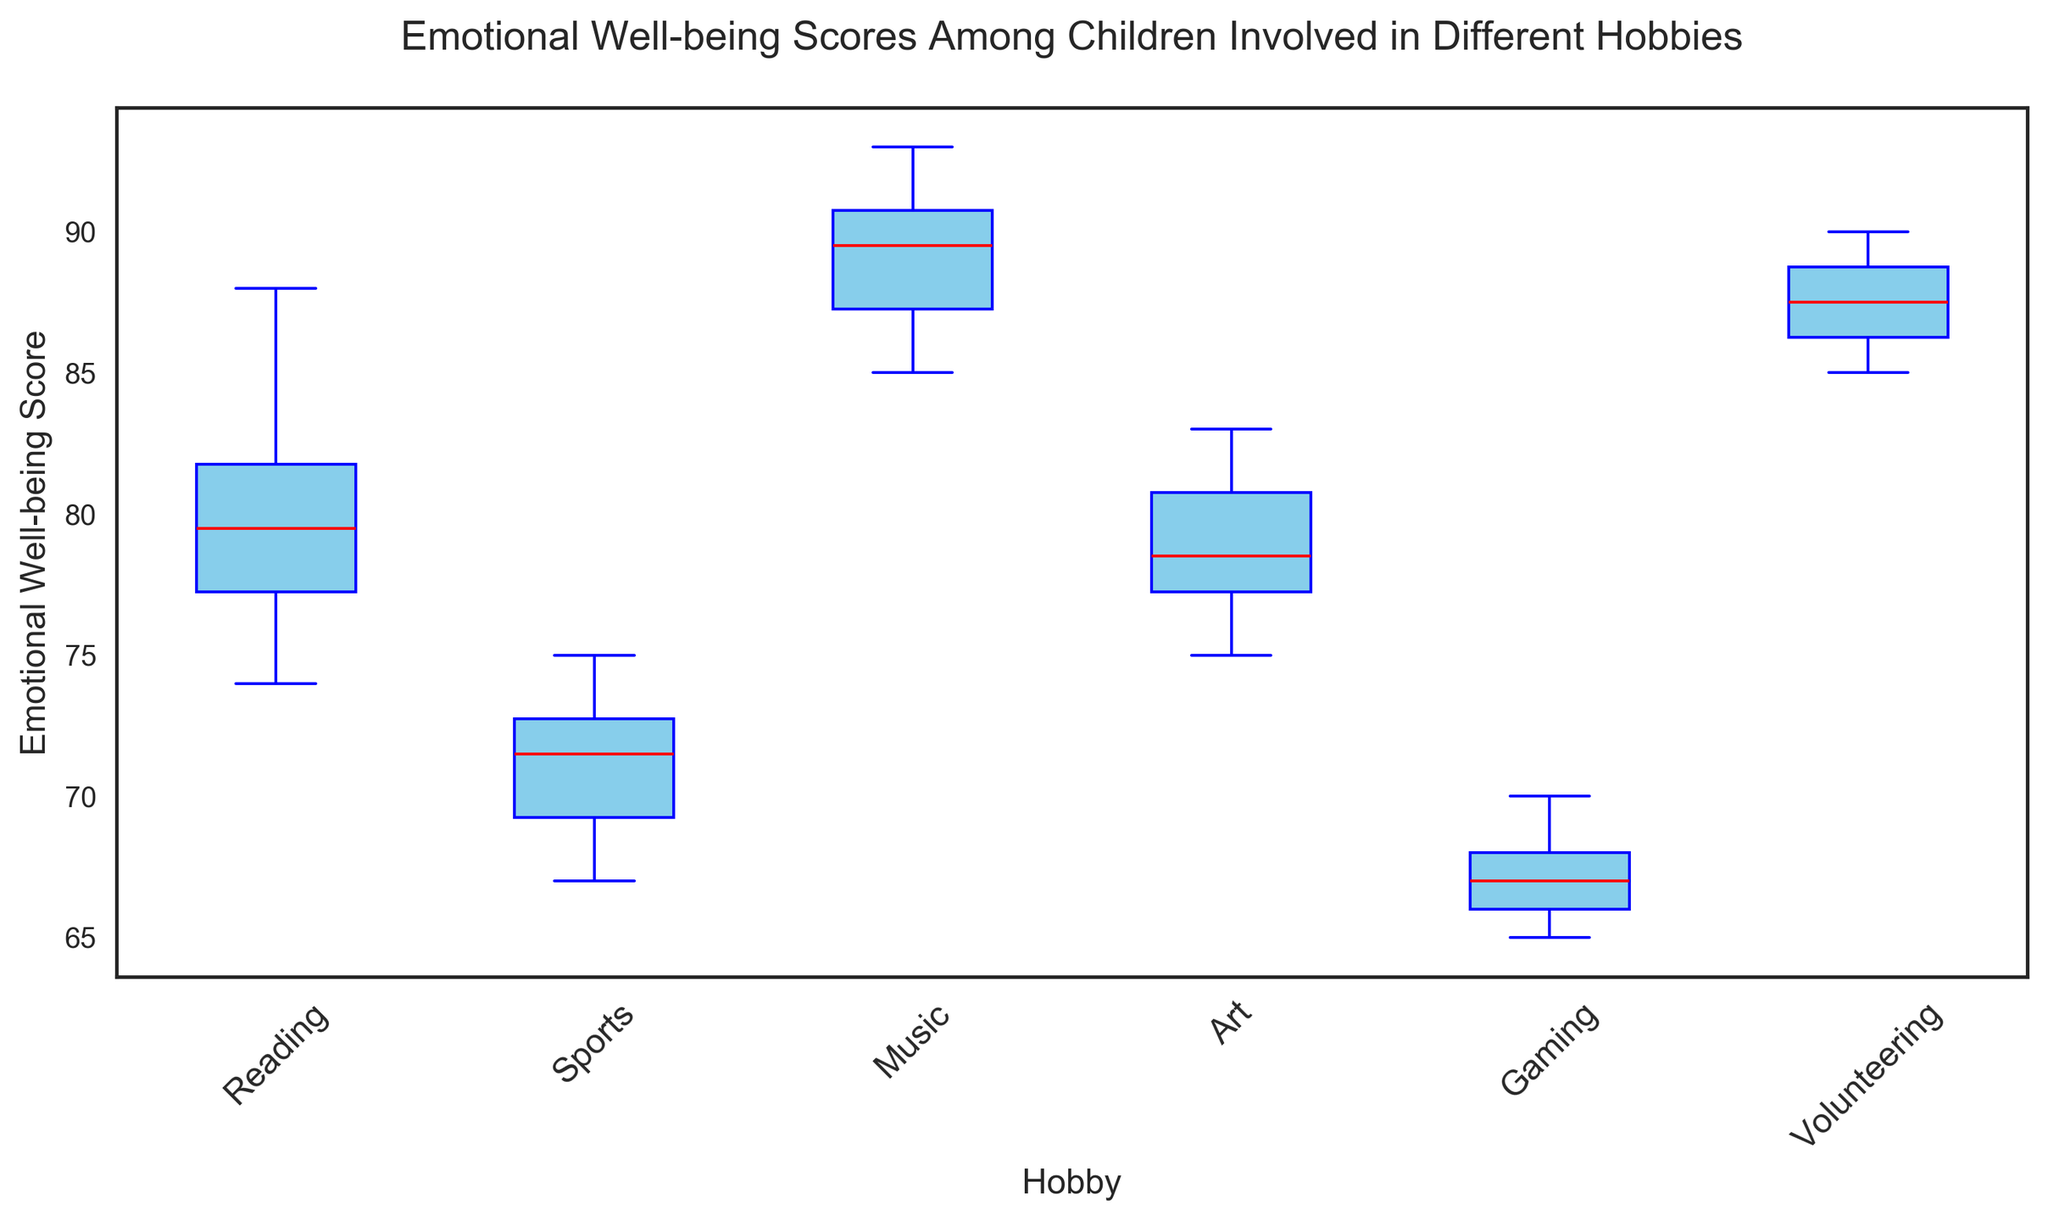What is the median emotional well-being score for children involved in music? To find the median, look at the value in the middle of the sorted data for music. In a box plot, the median is represented by the red line within the blue box for music.
Answer: 90 Which hobby has the lowest median emotional well-being score? Check the red lines within the blue boxes for each hobby and identify the hobby where this line is at the lowest position on the y-axis.
Answer: Gaming How do the median scores of children involved in sports compare to those involved in reading? Compare the red lines within the blue boxes for sports and reading, and see which is higher or lower on the y-axis.
Answer: Reading > Sports What's the range of the emotional well-being scores for children involved in volunteering? The range is the difference between the highest (top whisker) and the lowest (bottom whisker) scores in the box plot for volunteering.
Answer: 90 - 85 = 5 Which hobby shows the highest variability in emotional well-being scores? Variability is seen through the length of the box and whiskers. Identify the hobby with the longest box and whiskers combined.
Answer: Sports Are the emotional well-being scores for children involved in art more consistent than those for gaming? Consistency can be assessed by looking at the length of the box and whiskers. Shorter boxes and whiskers indicate more consistency. Compare art and gaming to see which has shorter box and whiskers.
Answer: Yes Does any hobby show any outliers in their emotional well-being scores? Outliers are typically shown as points outside the whiskers of the box plot. Check each hobby to see if there are any individual points away from the whiskers.
Answer: No Comparing the interquartile ranges (IQRs), which hobby has the narrowest spread of scores? The IQR is represented by the width of the blue boxes. Identify the hobby with the narrowest blue box.
Answer: Volunteering What is the median emotional well-being score for children involved in gaming? In the box plot, the median score is represented by the red line inside the blue box for gaming. Check the value corresponding to this line.
Answer: 67 How does the upper quartile for music compare to the upper quartile for art? The upper quartile is the top of the blue box. Compare the top of the blue boxes for music and art to determine which is higher.
Answer: Music > Art 